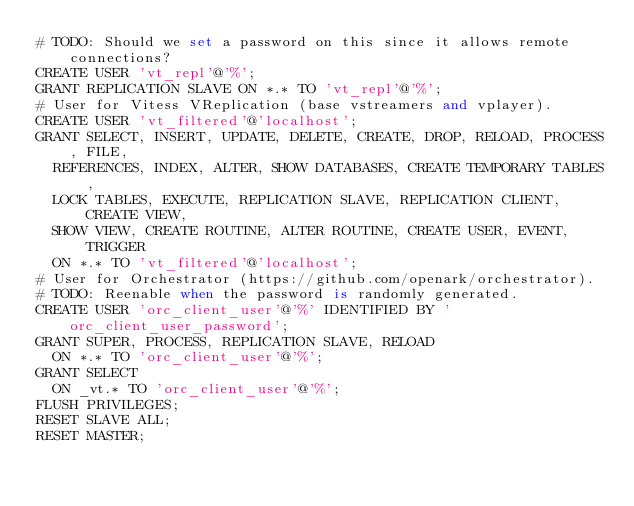<code> <loc_0><loc_0><loc_500><loc_500><_SQL_># TODO: Should we set a password on this since it allows remote connections?
CREATE USER 'vt_repl'@'%';
GRANT REPLICATION SLAVE ON *.* TO 'vt_repl'@'%';
# User for Vitess VReplication (base vstreamers and vplayer).
CREATE USER 'vt_filtered'@'localhost';
GRANT SELECT, INSERT, UPDATE, DELETE, CREATE, DROP, RELOAD, PROCESS, FILE,
  REFERENCES, INDEX, ALTER, SHOW DATABASES, CREATE TEMPORARY TABLES,
  LOCK TABLES, EXECUTE, REPLICATION SLAVE, REPLICATION CLIENT, CREATE VIEW,
  SHOW VIEW, CREATE ROUTINE, ALTER ROUTINE, CREATE USER, EVENT, TRIGGER
  ON *.* TO 'vt_filtered'@'localhost';
# User for Orchestrator (https://github.com/openark/orchestrator).
# TODO: Reenable when the password is randomly generated.
CREATE USER 'orc_client_user'@'%' IDENTIFIED BY 'orc_client_user_password';
GRANT SUPER, PROCESS, REPLICATION SLAVE, RELOAD
  ON *.* TO 'orc_client_user'@'%';
GRANT SELECT
  ON _vt.* TO 'orc_client_user'@'%';
FLUSH PRIVILEGES;
RESET SLAVE ALL;
RESET MASTER;
</code> 